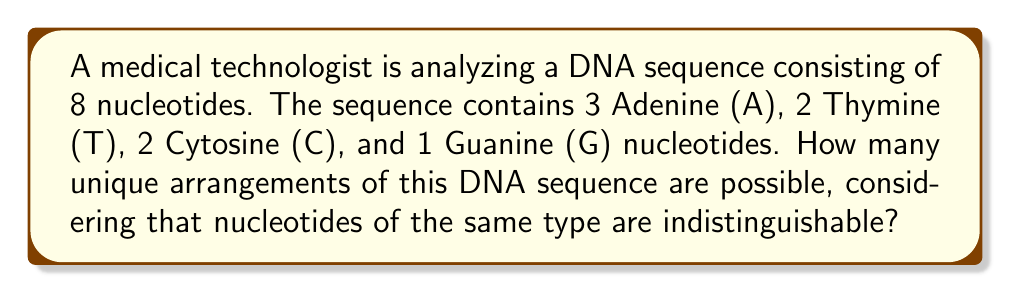Can you answer this question? To solve this problem, we need to use the concept of permutations with repetition from group theory. 

1) First, let's consider the total number of ways to arrange 8 distinct objects. This would be 8! (8 factorial).

2) However, in this case, we have repeated elements (3 A's, 2 T's, 2 C's, and 1 G). We need to account for these repetitions.

3) The number of ways to arrange objects with repetition is given by the formula:

   $$\frac{n!}{n_1! \cdot n_2! \cdot ... \cdot n_k!}$$

   Where $n$ is the total number of objects, and $n_1, n_2, ..., n_k$ are the numbers of each type of object.

4) In our case:
   $n = 8$ (total nucleotides)
   $n_1 = 3$ (Adenine)
   $n_2 = 2$ (Thymine)
   $n_3 = 2$ (Cytosine)
   $n_4 = 1$ (Guanine)

5) Plugging these values into our formula:

   $$\text{Number of unique arrangements} = \frac{8!}{3! \cdot 2! \cdot 2! \cdot 1!}$$

6) Let's calculate this:
   
   $$\frac{8!}{3! \cdot 2! \cdot 2! \cdot 1!} = \frac{40,320}{6 \cdot 2 \cdot 2 \cdot 1} = \frac{40,320}{24} = 1,680$$

Therefore, there are 1,680 unique arrangements of this DNA sequence.
Answer: 1,680 unique arrangements 